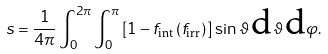<formula> <loc_0><loc_0><loc_500><loc_500>s = \frac { 1 } { 4 \pi } \int _ { 0 } ^ { 2 \pi } \int _ { 0 } ^ { \pi } \left [ 1 - f _ { \text {int} } \left ( f _ { \text {irr} } \right ) \right ] \, \sin \vartheta \, \text {d} \vartheta \, \text {d} \varphi .</formula> 